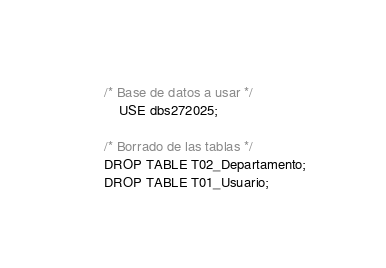<code> <loc_0><loc_0><loc_500><loc_500><_SQL_>/* Base de datos a usar */
    USE dbs272025;

/* Borrado de las tablas */
DROP TABLE T02_Departamento;
DROP TABLE T01_Usuario;</code> 